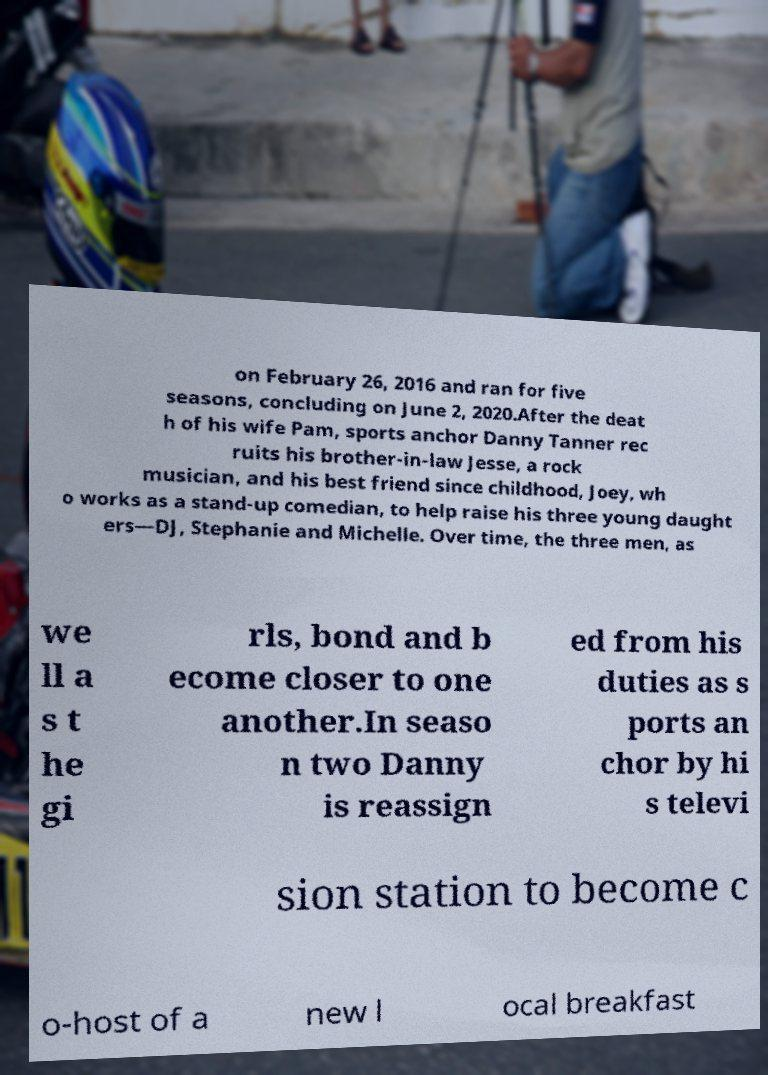Can you accurately transcribe the text from the provided image for me? on February 26, 2016 and ran for five seasons, concluding on June 2, 2020.After the deat h of his wife Pam, sports anchor Danny Tanner rec ruits his brother-in-law Jesse, a rock musician, and his best friend since childhood, Joey, wh o works as a stand-up comedian, to help raise his three young daught ers—DJ, Stephanie and Michelle. Over time, the three men, as we ll a s t he gi rls, bond and b ecome closer to one another.In seaso n two Danny is reassign ed from his duties as s ports an chor by hi s televi sion station to become c o-host of a new l ocal breakfast 